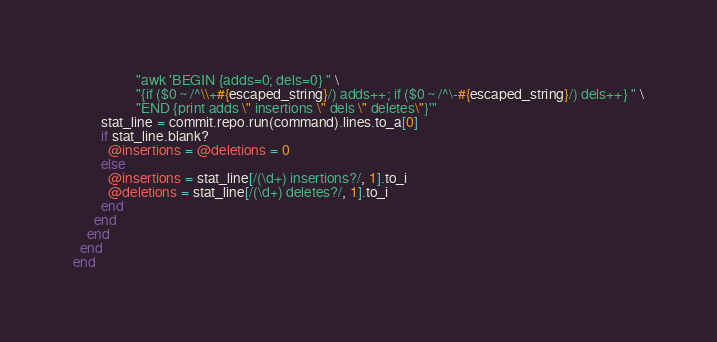Convert code to text. <code><loc_0><loc_0><loc_500><loc_500><_Ruby_>                  "awk 'BEGIN {adds=0; dels=0} " \
                  "{if ($0 ~ /^\\+#{escaped_string}/) adds++; if ($0 ~ /^\-#{escaped_string}/) dels++} " \
                  "END {print adds \" insertions \" dels \" deletes\"}'"
        stat_line = commit.repo.run(command).lines.to_a[0]
        if stat_line.blank?
          @insertions = @deletions = 0
        else
          @insertions = stat_line[/(\d+) insertions?/, 1].to_i
          @deletions = stat_line[/(\d+) deletes?/, 1].to_i
        end
      end
    end
  end
end
</code> 